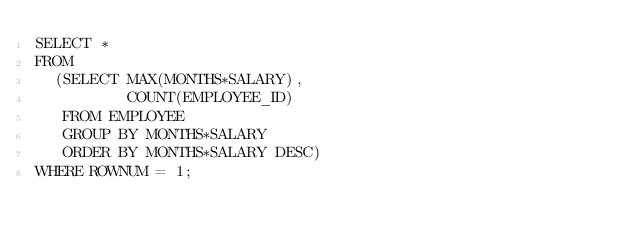Convert code to text. <code><loc_0><loc_0><loc_500><loc_500><_SQL_>SELECT *
FROM
  (SELECT MAX(MONTHS*SALARY),
          COUNT(EMPLOYEE_ID)
   FROM EMPLOYEE
   GROUP BY MONTHS*SALARY
   ORDER BY MONTHS*SALARY DESC)
WHERE ROWNUM = 1;</code> 